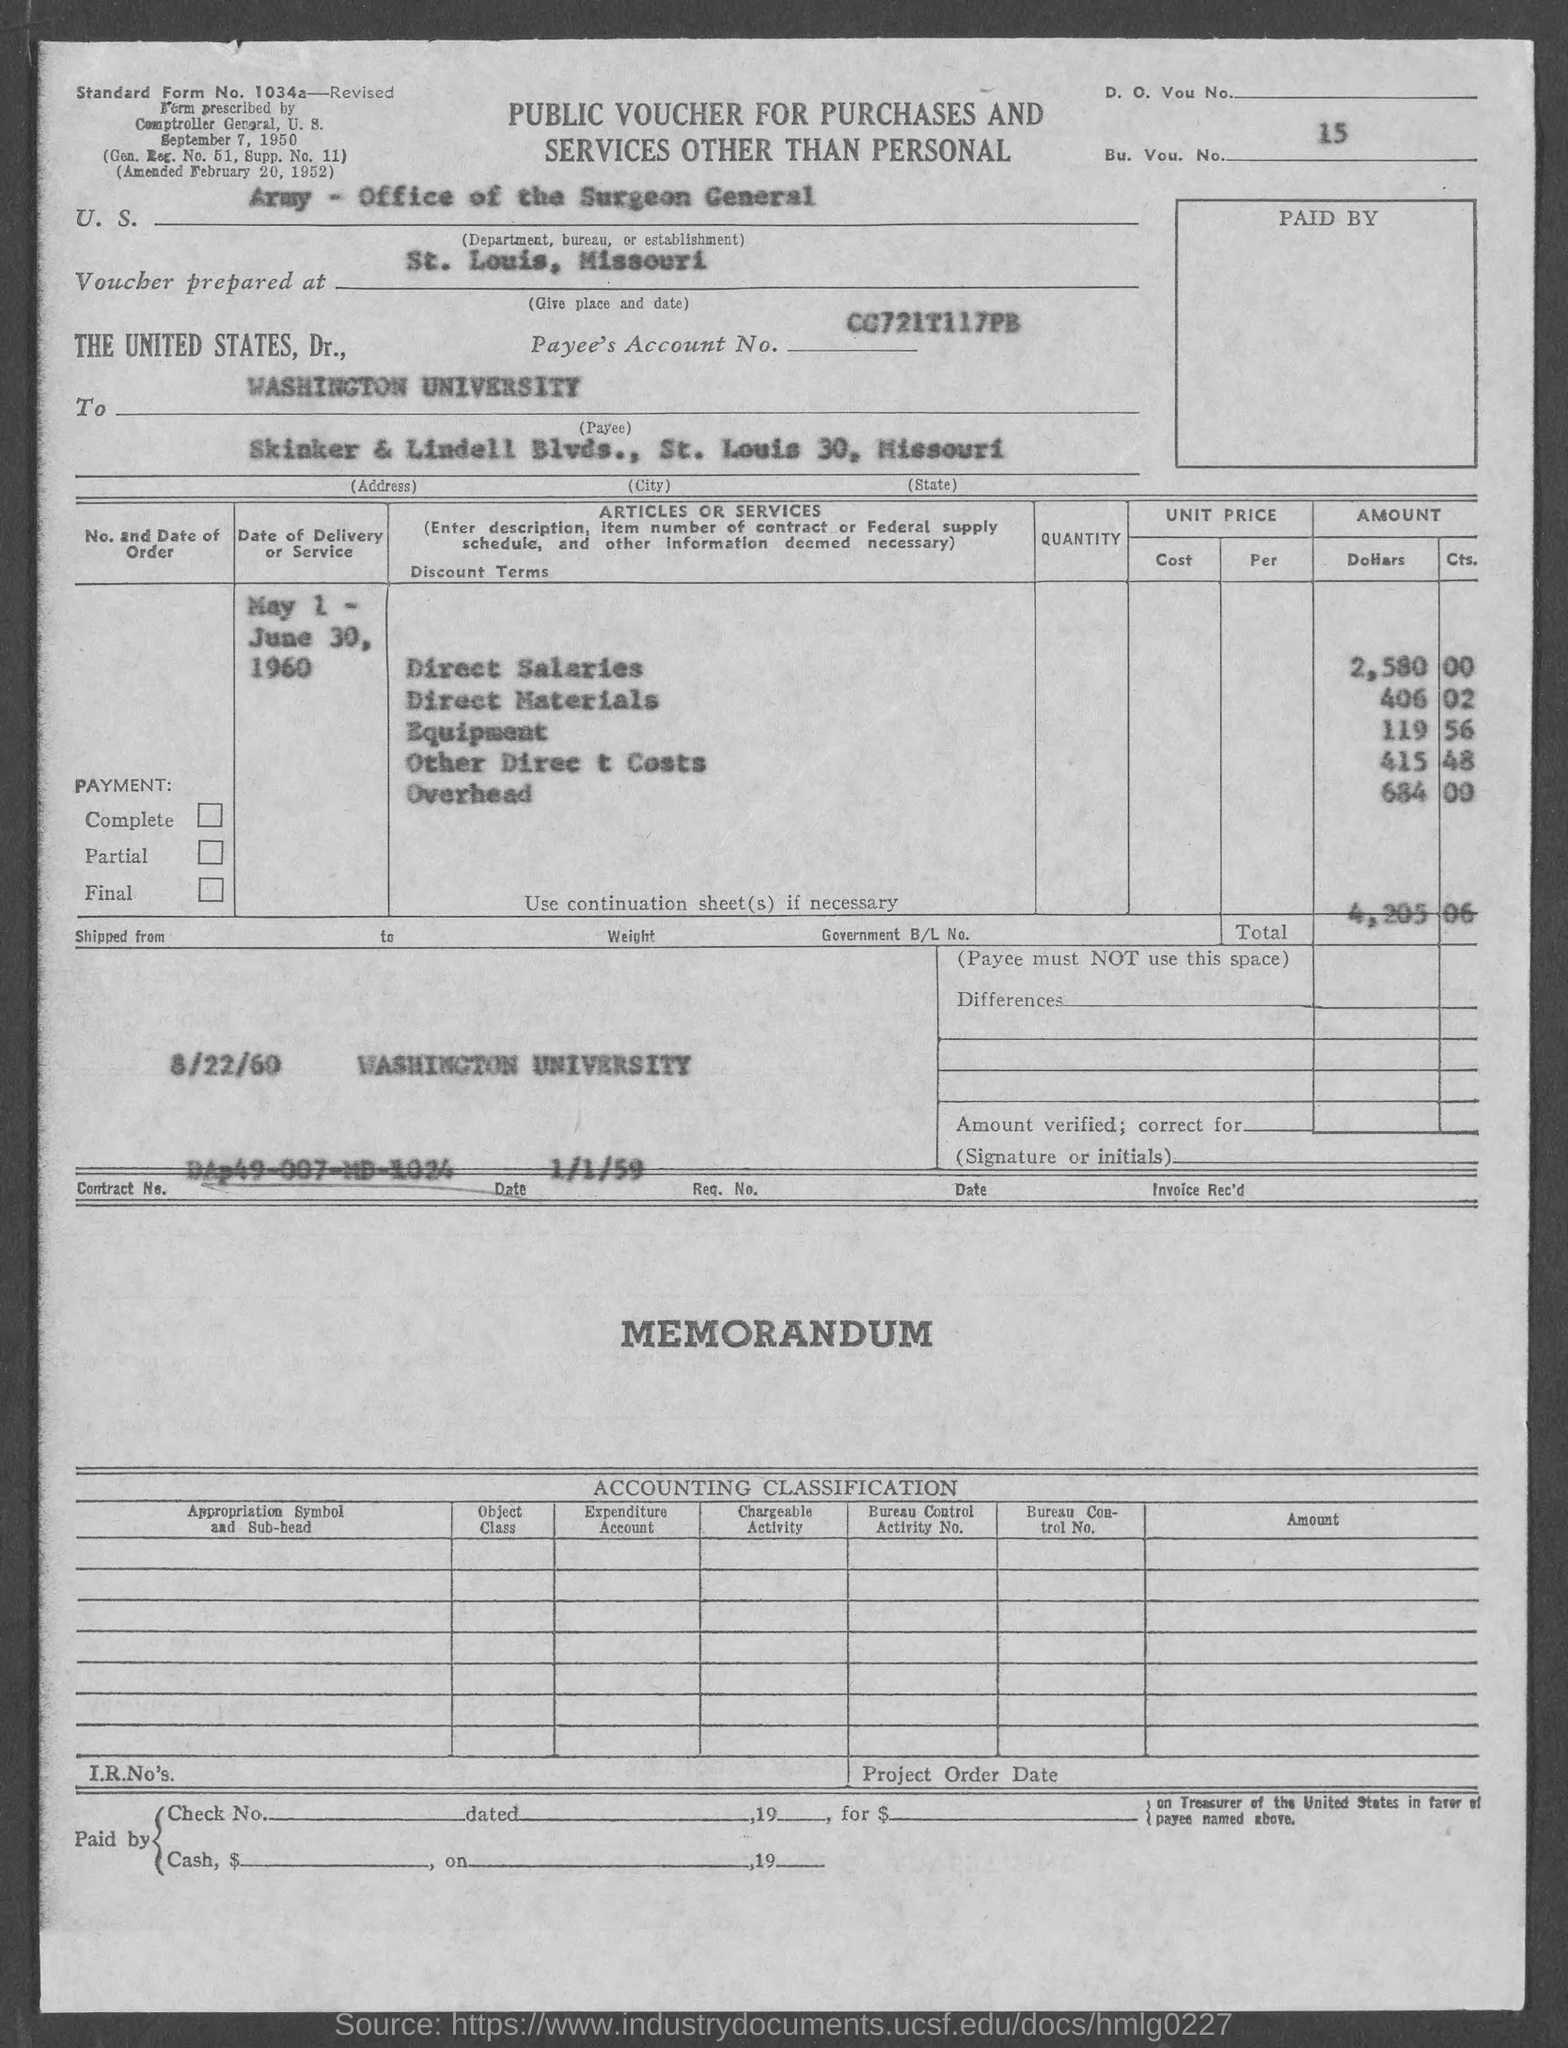Mention a couple of crucial points in this snapshot. The amount of other direct costs is 415 and 48... What is the BU. VOU. number? Standard form number 1034a has been requested. The amount of Equipment is 119 and the amount of Supplies is 56. The amount of overhead is 684.00. 